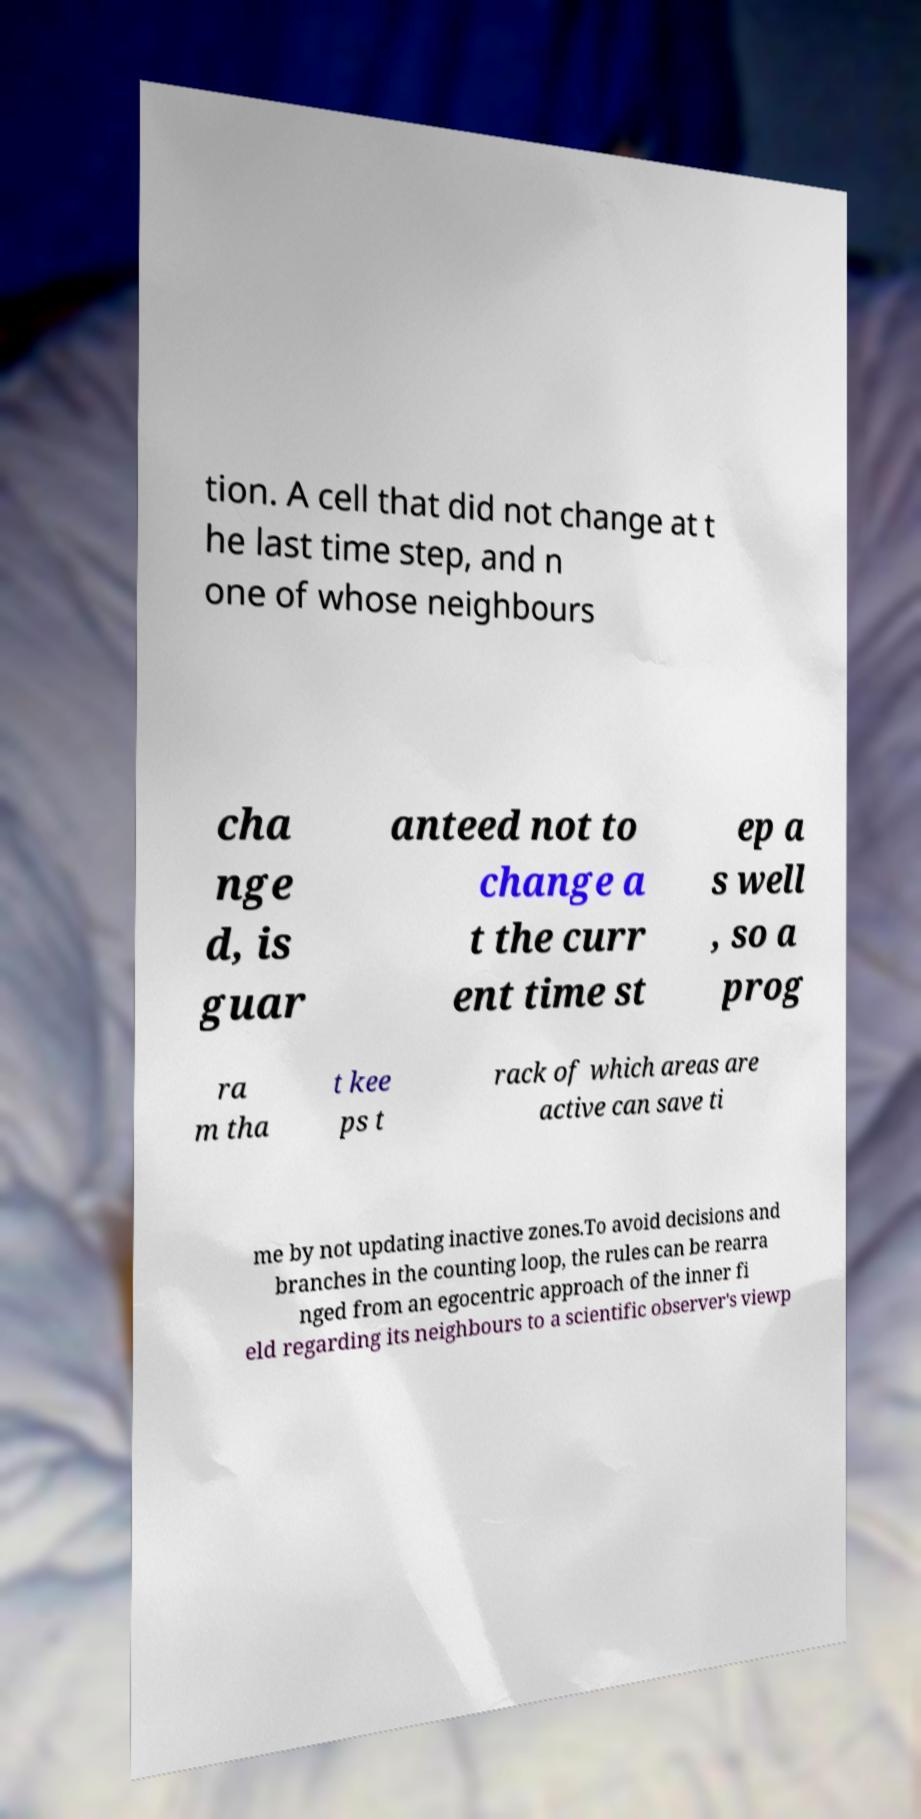For documentation purposes, I need the text within this image transcribed. Could you provide that? tion. A cell that did not change at t he last time step, and n one of whose neighbours cha nge d, is guar anteed not to change a t the curr ent time st ep a s well , so a prog ra m tha t kee ps t rack of which areas are active can save ti me by not updating inactive zones.To avoid decisions and branches in the counting loop, the rules can be rearra nged from an egocentric approach of the inner fi eld regarding its neighbours to a scientific observer's viewp 